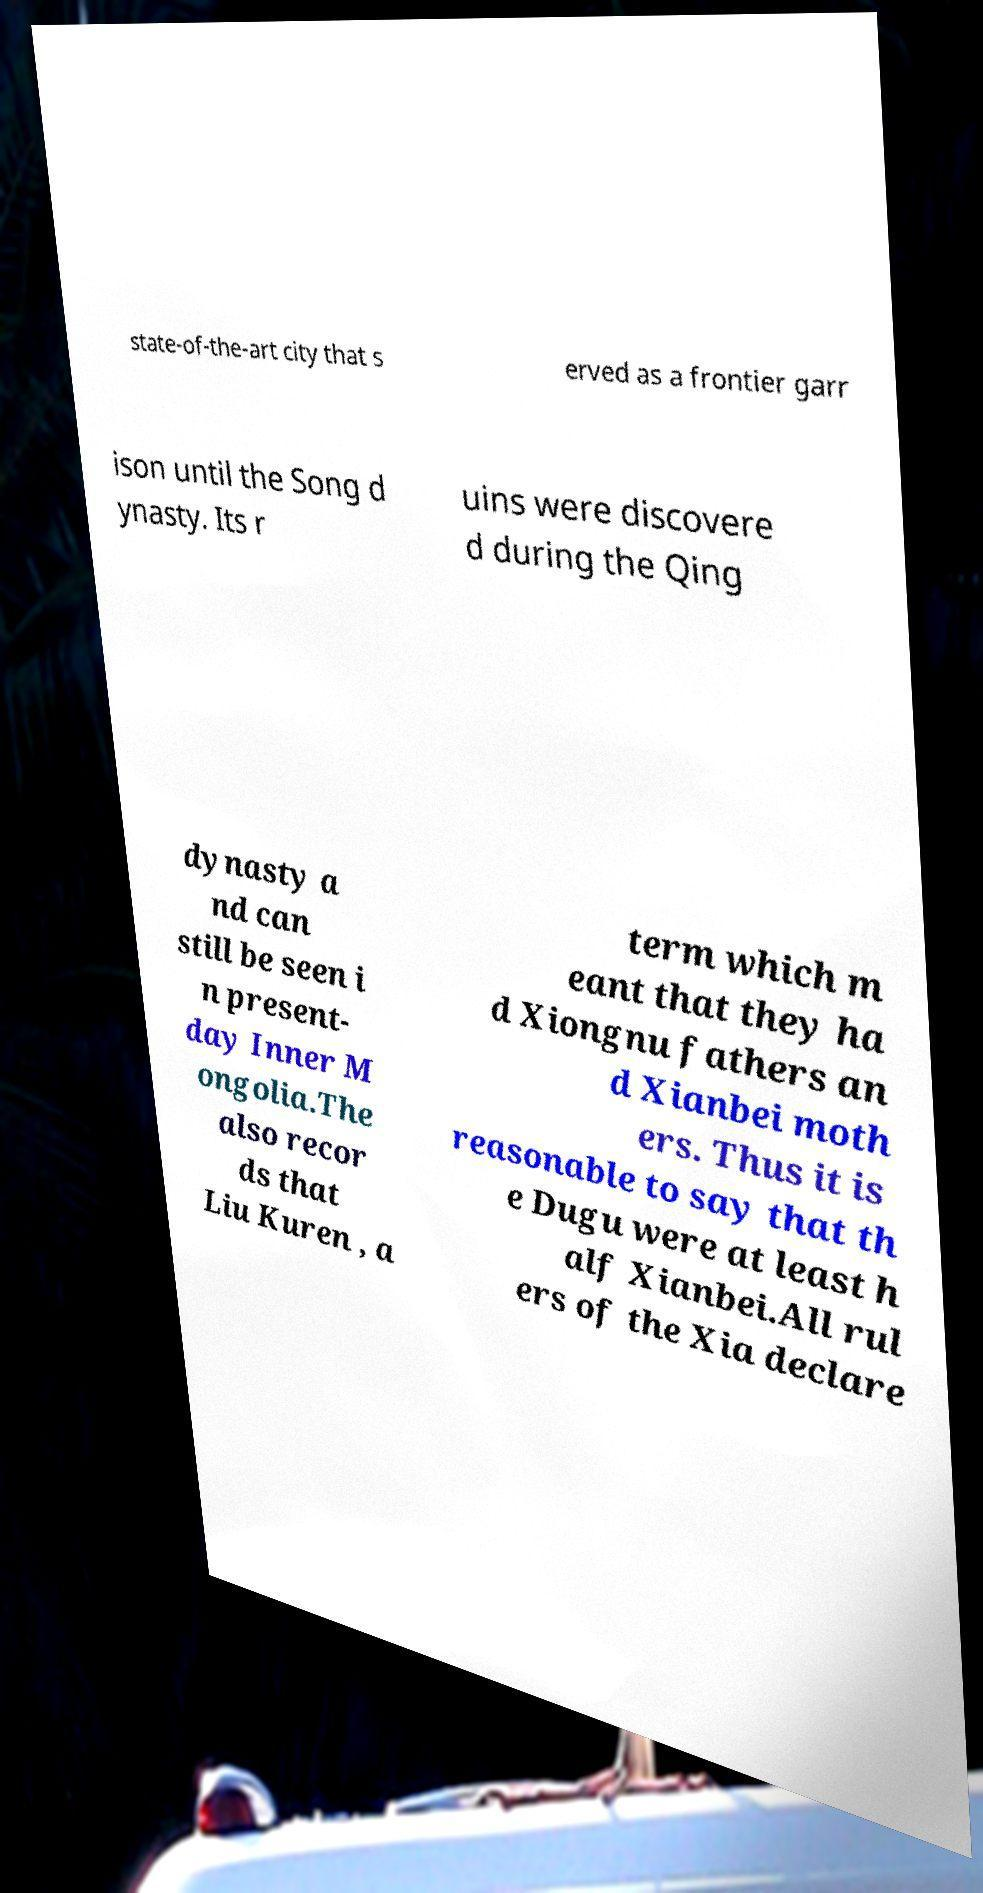There's text embedded in this image that I need extracted. Can you transcribe it verbatim? state-of-the-art city that s erved as a frontier garr ison until the Song d ynasty. Its r uins were discovere d during the Qing dynasty a nd can still be seen i n present- day Inner M ongolia.The also recor ds that Liu Kuren , a term which m eant that they ha d Xiongnu fathers an d Xianbei moth ers. Thus it is reasonable to say that th e Dugu were at least h alf Xianbei.All rul ers of the Xia declare 